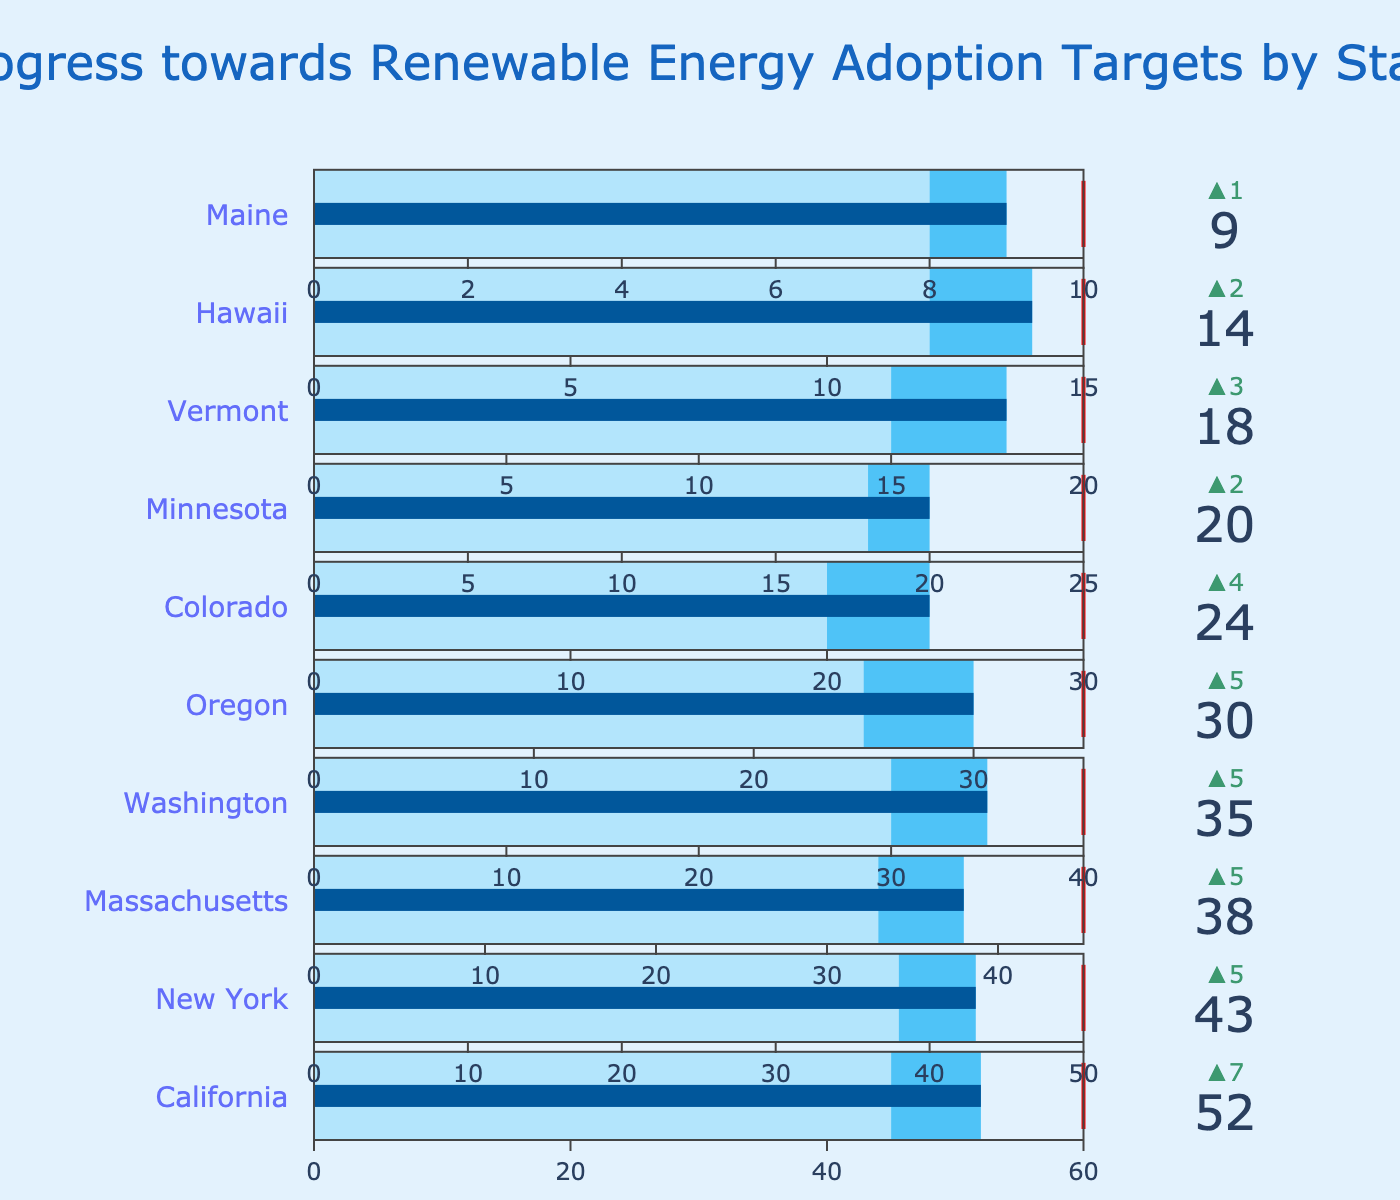What is the title of the figure? The title is found at the top of the figure. It typically summarizes the main purpose or content of the chart.
Answer: Progress towards Renewable Energy Adoption Targets by State How many states are represented in the figure? By counting the number of state names that appear next to each bullet chart, you can determine the representation.
Answer: 10 Which state has the highest renewable energy adoption target? Look for the state with the largest number in the "Target" section of the bullet chart.
Answer: California For which state is the actual renewable energy adoption closest to its comparison value? Compare the actual and comparison values for each state and identify the smallest difference.
Answer: Hawaii Which state is the furthest from reaching its target? Identify the state where the actual value is the smallest fraction of the target value.
Answer: Hawaii What is the average renewable energy adoption target across all states? Sum all the target values and divide by the number of states (10). Sum = 60 + 50 + 45 + 40 + 35 + 30 + 25 + 20 + 15 + 10 = 330; Average = 330/10 = 33
Answer: 33 Which state has the greatest delta between its actual and comparison values? Calculate the difference between actual and comparison values for each state and find the maximum.
Answer: New York Which state has an actual value of 24 for renewable energy adoption? Look for the state where the actual value in the bullet chart is 24.
Answer: Colorado How much more does California need to achieve its renewable energy adoption target? Subtract the actual value for California from its target value (Target - Actual). 60 - 52 = 8
Answer: 8 Which state has the lowest comparison value for renewable energy adoption? Identify the state with the smallest number in the "Comparison" section of the bullet chart.
Answer: Maine 